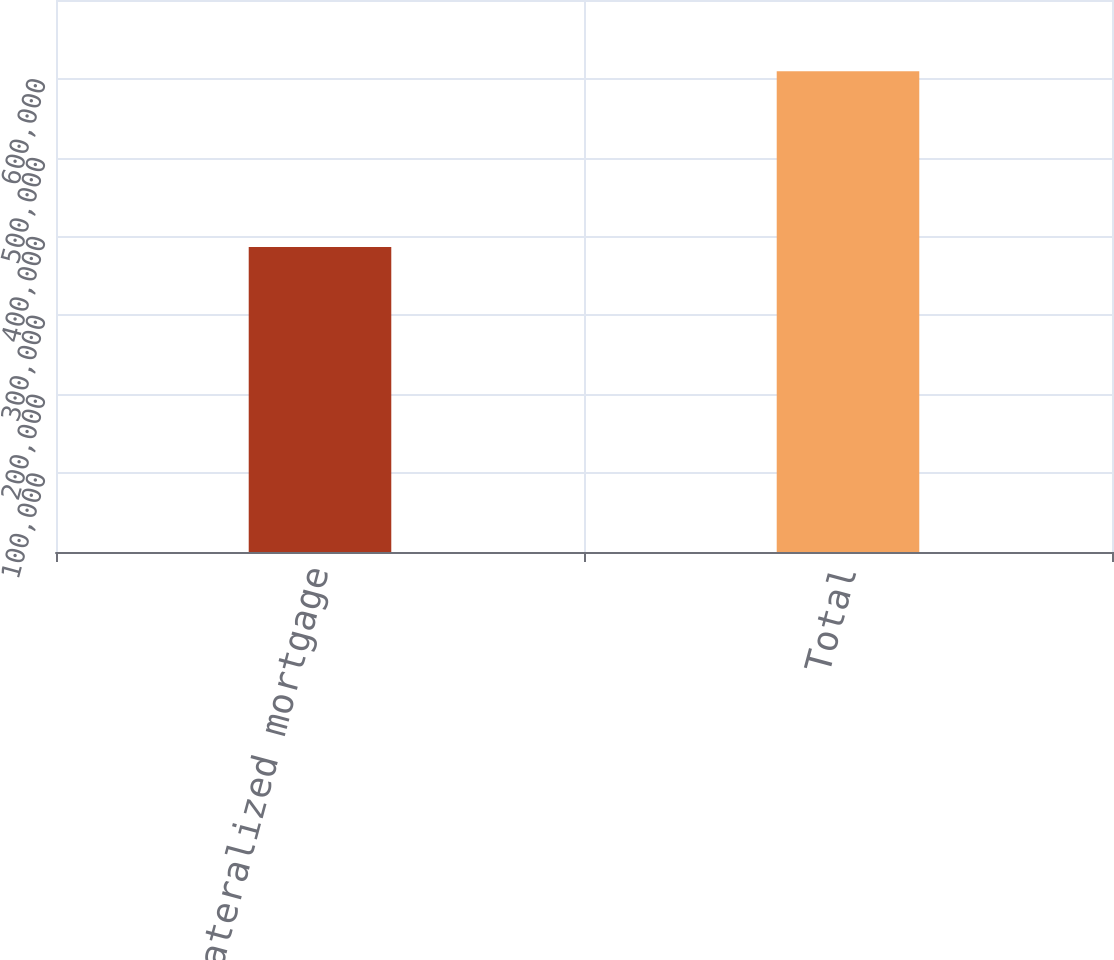<chart> <loc_0><loc_0><loc_500><loc_500><bar_chart><fcel>Collateralized mortgage<fcel>Total<nl><fcel>386706<fcel>609706<nl></chart> 